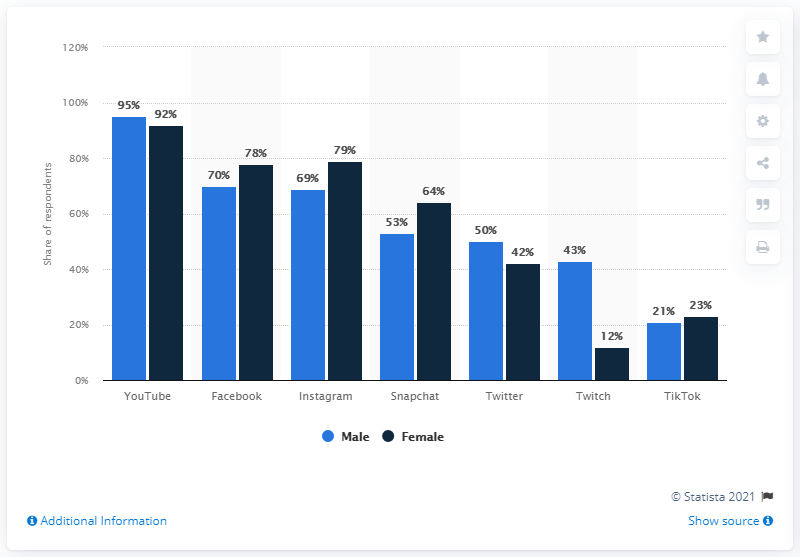Give some essential details in this illustration. What is the value of the bar with the rightmost blue stripe? 21. The highest value between the rightmost light blue bar and dark blue bar is 23. According to the given information, Facebook is the social media platform that had the highest reach among Gen Z and Millennials. 